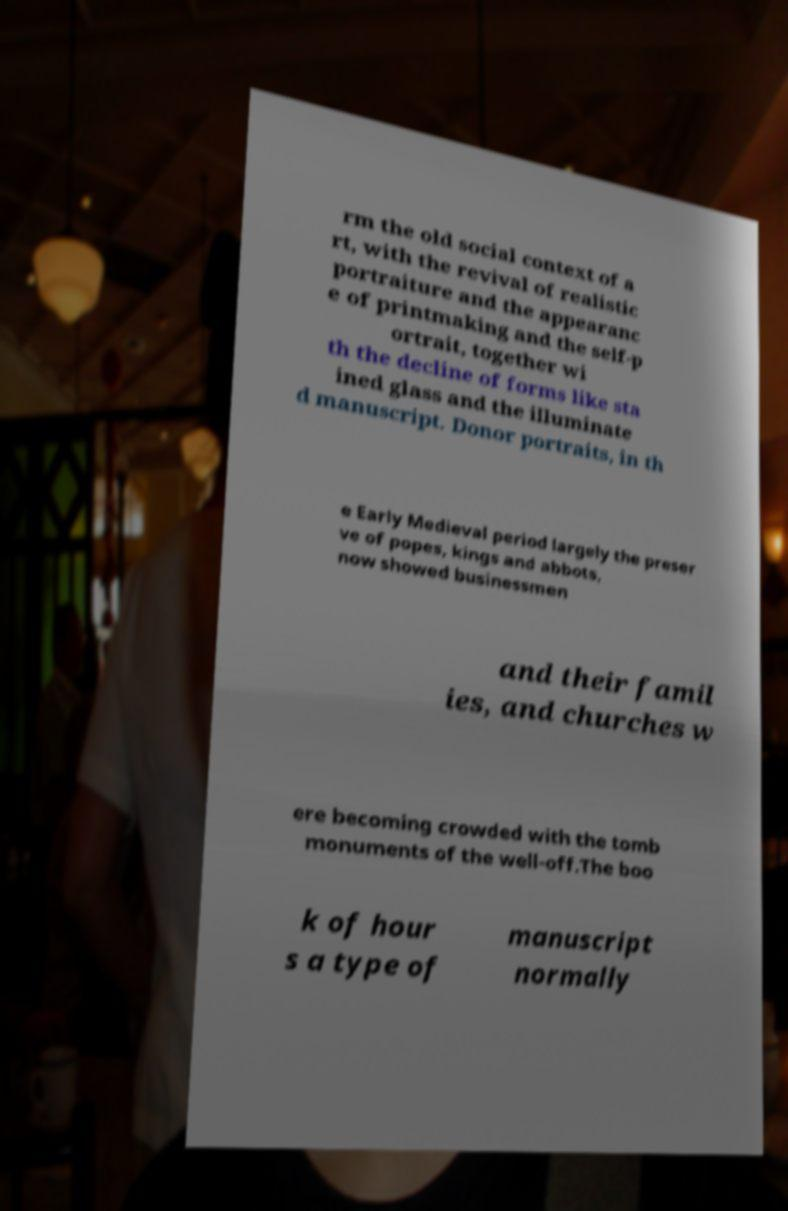I need the written content from this picture converted into text. Can you do that? rm the old social context of a rt, with the revival of realistic portraiture and the appearanc e of printmaking and the self-p ortrait, together wi th the decline of forms like sta ined glass and the illuminate d manuscript. Donor portraits, in th e Early Medieval period largely the preser ve of popes, kings and abbots, now showed businessmen and their famil ies, and churches w ere becoming crowded with the tomb monuments of the well-off.The boo k of hour s a type of manuscript normally 